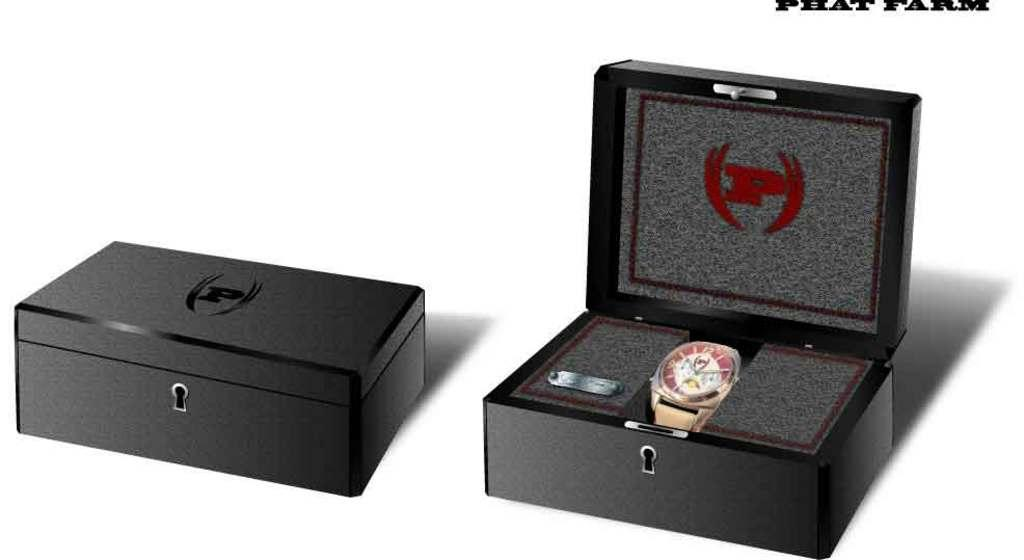<image>
Share a concise interpretation of the image provided. A timepiece in a black box is made by the Phat Farm company. 